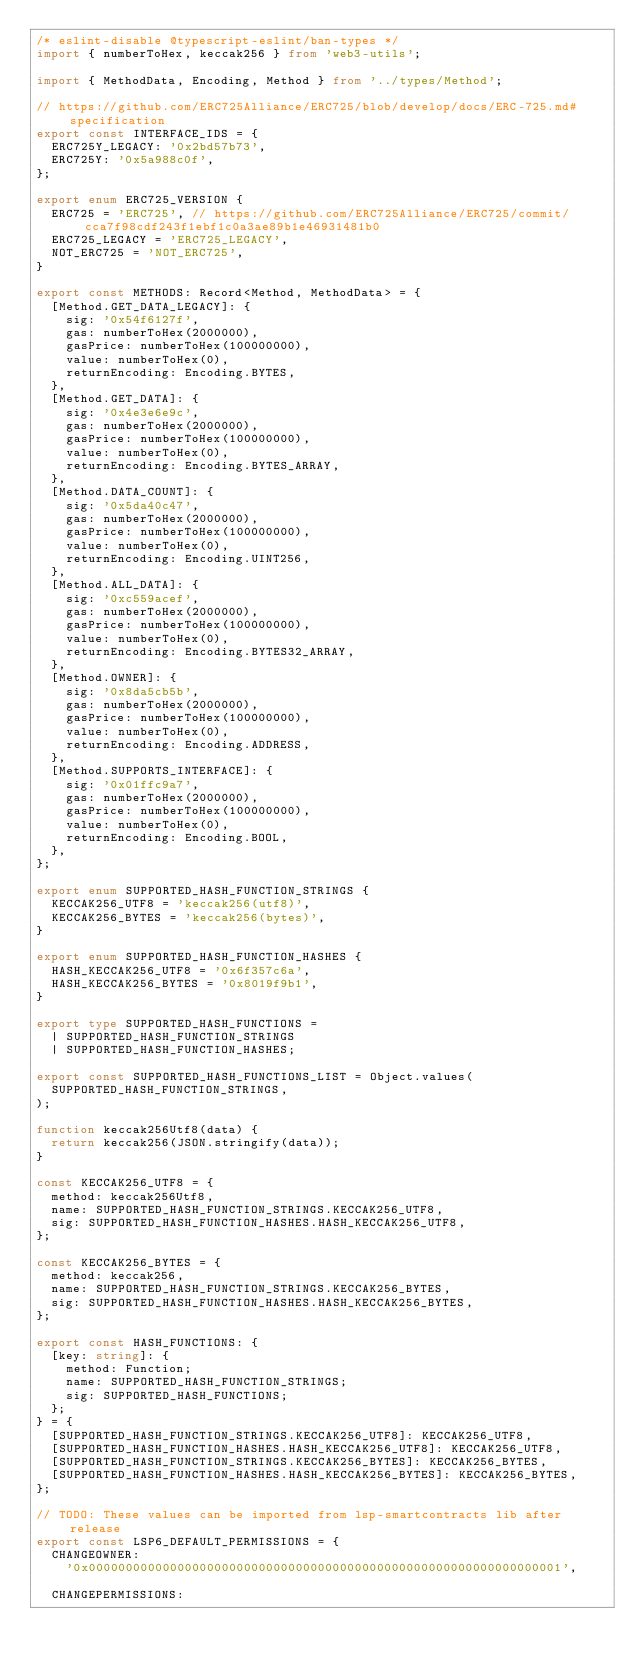Convert code to text. <code><loc_0><loc_0><loc_500><loc_500><_TypeScript_>/* eslint-disable @typescript-eslint/ban-types */
import { numberToHex, keccak256 } from 'web3-utils';

import { MethodData, Encoding, Method } from '../types/Method';

// https://github.com/ERC725Alliance/ERC725/blob/develop/docs/ERC-725.md#specification
export const INTERFACE_IDS = {
  ERC725Y_LEGACY: '0x2bd57b73',
  ERC725Y: '0x5a988c0f',
};

export enum ERC725_VERSION {
  ERC725 = 'ERC725', // https://github.com/ERC725Alliance/ERC725/commit/cca7f98cdf243f1ebf1c0a3ae89b1e46931481b0
  ERC725_LEGACY = 'ERC725_LEGACY',
  NOT_ERC725 = 'NOT_ERC725',
}

export const METHODS: Record<Method, MethodData> = {
  [Method.GET_DATA_LEGACY]: {
    sig: '0x54f6127f',
    gas: numberToHex(2000000),
    gasPrice: numberToHex(100000000),
    value: numberToHex(0),
    returnEncoding: Encoding.BYTES,
  },
  [Method.GET_DATA]: {
    sig: '0x4e3e6e9c',
    gas: numberToHex(2000000),
    gasPrice: numberToHex(100000000),
    value: numberToHex(0),
    returnEncoding: Encoding.BYTES_ARRAY,
  },
  [Method.DATA_COUNT]: {
    sig: '0x5da40c47',
    gas: numberToHex(2000000),
    gasPrice: numberToHex(100000000),
    value: numberToHex(0),
    returnEncoding: Encoding.UINT256,
  },
  [Method.ALL_DATA]: {
    sig: '0xc559acef',
    gas: numberToHex(2000000),
    gasPrice: numberToHex(100000000),
    value: numberToHex(0),
    returnEncoding: Encoding.BYTES32_ARRAY,
  },
  [Method.OWNER]: {
    sig: '0x8da5cb5b',
    gas: numberToHex(2000000),
    gasPrice: numberToHex(100000000),
    value: numberToHex(0),
    returnEncoding: Encoding.ADDRESS,
  },
  [Method.SUPPORTS_INTERFACE]: {
    sig: '0x01ffc9a7',
    gas: numberToHex(2000000),
    gasPrice: numberToHex(100000000),
    value: numberToHex(0),
    returnEncoding: Encoding.BOOL,
  },
};

export enum SUPPORTED_HASH_FUNCTION_STRINGS {
  KECCAK256_UTF8 = 'keccak256(utf8)',
  KECCAK256_BYTES = 'keccak256(bytes)',
}

export enum SUPPORTED_HASH_FUNCTION_HASHES {
  HASH_KECCAK256_UTF8 = '0x6f357c6a',
  HASH_KECCAK256_BYTES = '0x8019f9b1',
}

export type SUPPORTED_HASH_FUNCTIONS =
  | SUPPORTED_HASH_FUNCTION_STRINGS
  | SUPPORTED_HASH_FUNCTION_HASHES;

export const SUPPORTED_HASH_FUNCTIONS_LIST = Object.values(
  SUPPORTED_HASH_FUNCTION_STRINGS,
);

function keccak256Utf8(data) {
  return keccak256(JSON.stringify(data));
}

const KECCAK256_UTF8 = {
  method: keccak256Utf8,
  name: SUPPORTED_HASH_FUNCTION_STRINGS.KECCAK256_UTF8,
  sig: SUPPORTED_HASH_FUNCTION_HASHES.HASH_KECCAK256_UTF8,
};

const KECCAK256_BYTES = {
  method: keccak256,
  name: SUPPORTED_HASH_FUNCTION_STRINGS.KECCAK256_BYTES,
  sig: SUPPORTED_HASH_FUNCTION_HASHES.HASH_KECCAK256_BYTES,
};

export const HASH_FUNCTIONS: {
  [key: string]: {
    method: Function;
    name: SUPPORTED_HASH_FUNCTION_STRINGS;
    sig: SUPPORTED_HASH_FUNCTIONS;
  };
} = {
  [SUPPORTED_HASH_FUNCTION_STRINGS.KECCAK256_UTF8]: KECCAK256_UTF8,
  [SUPPORTED_HASH_FUNCTION_HASHES.HASH_KECCAK256_UTF8]: KECCAK256_UTF8,
  [SUPPORTED_HASH_FUNCTION_STRINGS.KECCAK256_BYTES]: KECCAK256_BYTES,
  [SUPPORTED_HASH_FUNCTION_HASHES.HASH_KECCAK256_BYTES]: KECCAK256_BYTES,
};

// TODO: These values can be imported from lsp-smartcontracts lib after release
export const LSP6_DEFAULT_PERMISSIONS = {
  CHANGEOWNER:
    '0x0000000000000000000000000000000000000000000000000000000000000001',

  CHANGEPERMISSIONS:</code> 